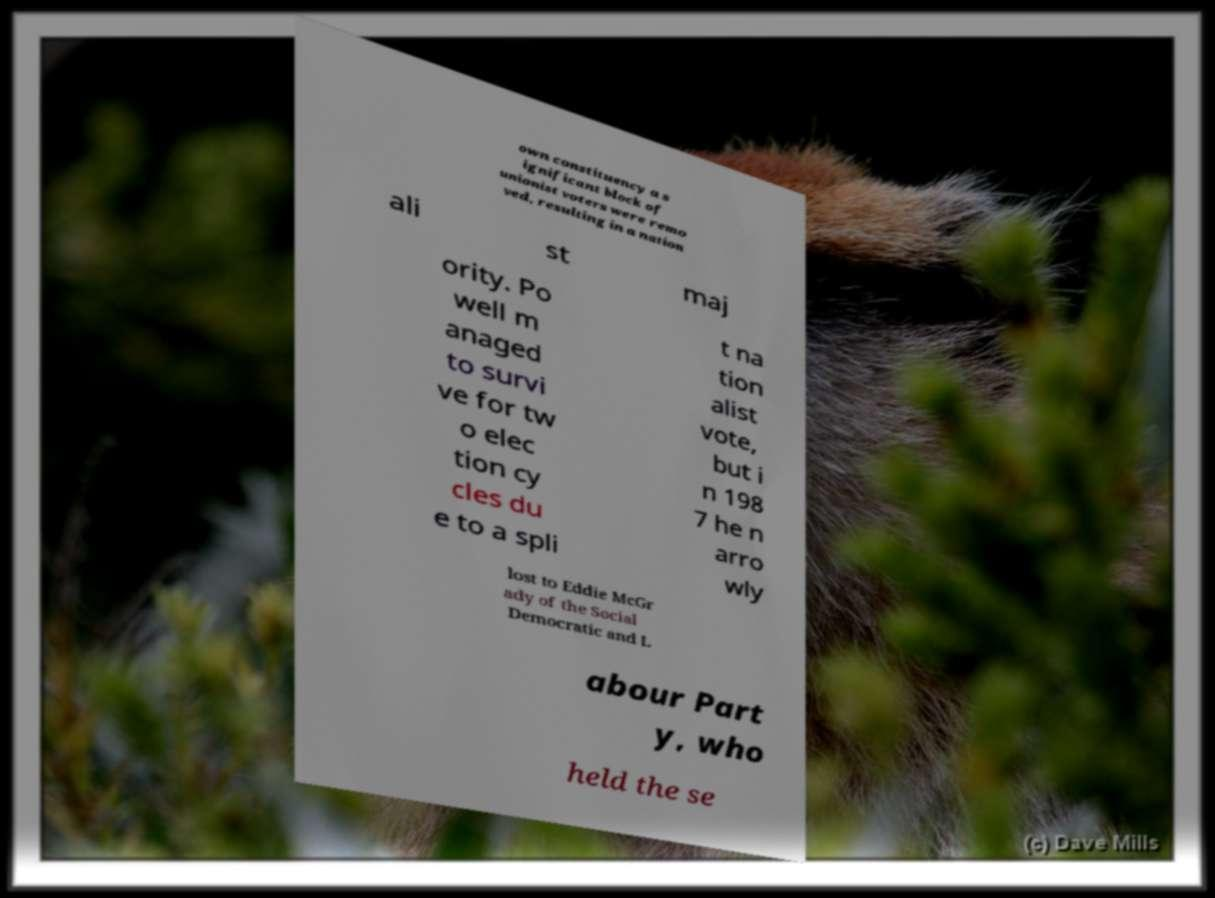Could you extract and type out the text from this image? own constituency a s ignificant block of unionist voters were remo ved, resulting in a nation ali st maj ority. Po well m anaged to survi ve for tw o elec tion cy cles du e to a spli t na tion alist vote, but i n 198 7 he n arro wly lost to Eddie McGr ady of the Social Democratic and L abour Part y, who held the se 